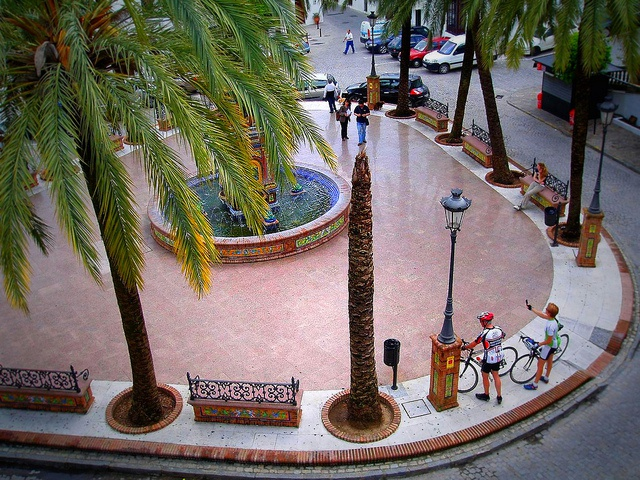Describe the objects in this image and their specific colors. I can see bench in darkgreen, black, maroon, gray, and lightpink tones, bench in darkgreen, black, gray, and maroon tones, people in darkgreen, darkgray, black, and maroon tones, people in darkgreen, black, lavender, brown, and darkgray tones, and car in darkgreen, black, gray, and navy tones in this image. 